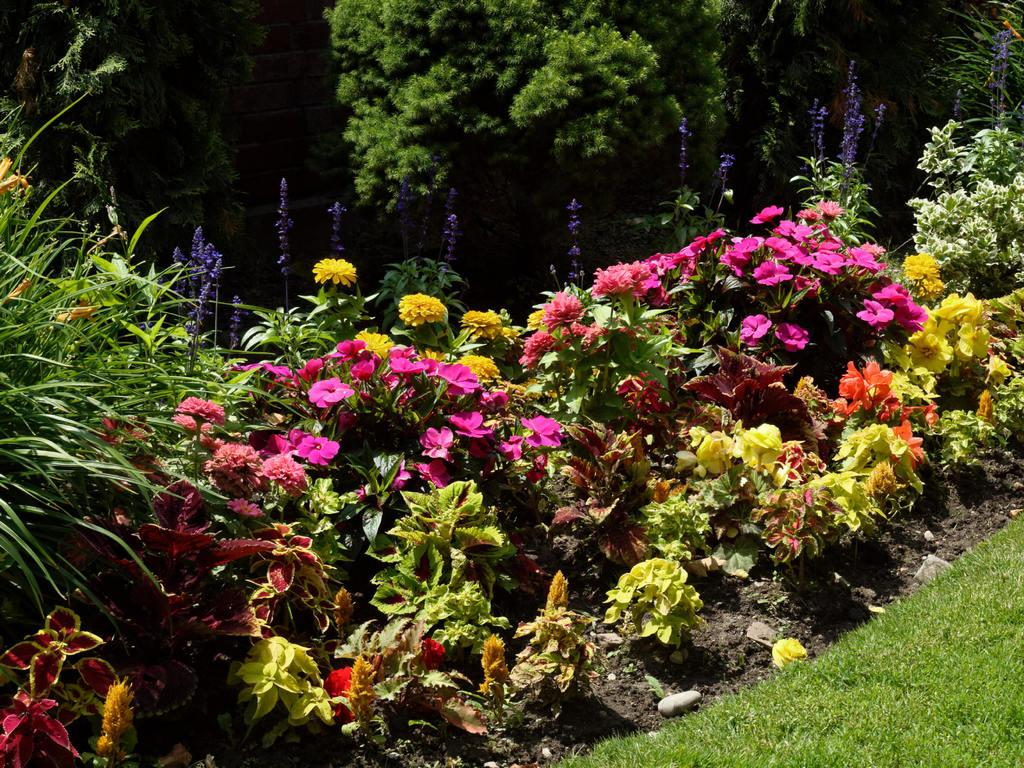What type of plants can be seen in the image? There are plants with flowers in the image. Where are the plants located? The plants are on a grassy land. What else can be seen in the background of the image? There are trees visible at the top of the image. What advice does the carpenter give to the channel in the image? There is no carpenter or channel present in the image, so no such advice can be given. 